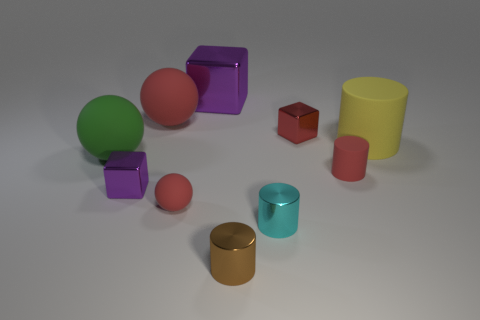What size is the other metal thing that is the same color as the big metal object?
Your answer should be compact. Small. There is a matte object that is on the right side of the small cylinder that is behind the cube that is on the left side of the large block; how big is it?
Make the answer very short. Large. What number of other green spheres have the same material as the tiny ball?
Ensure brevity in your answer.  1. How many blue cylinders have the same size as the cyan cylinder?
Your answer should be compact. 0. There is a red ball behind the red matte sphere that is in front of the big matte object that is right of the tiny cyan thing; what is its material?
Make the answer very short. Rubber. How many objects are either tiny brown shiny objects or cyan cubes?
Your answer should be very brief. 1. Is there any other thing that has the same material as the small purple object?
Your answer should be very brief. Yes. The brown thing is what shape?
Offer a terse response. Cylinder. There is a metallic object that is behind the sphere behind the yellow rubber cylinder; what is its shape?
Offer a terse response. Cube. Are the large purple block that is on the right side of the small ball and the brown cylinder made of the same material?
Make the answer very short. Yes. 